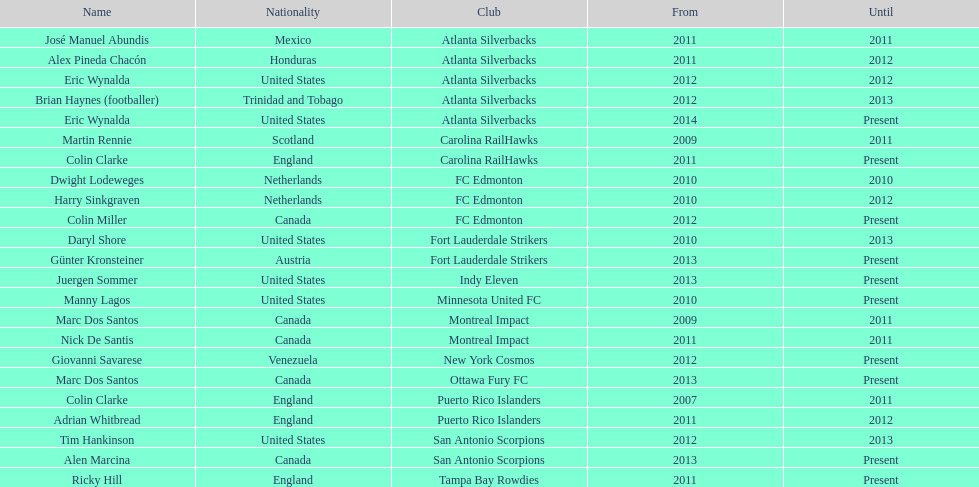How long did colin clarke coach the puerto rico islanders for? 4 years. 